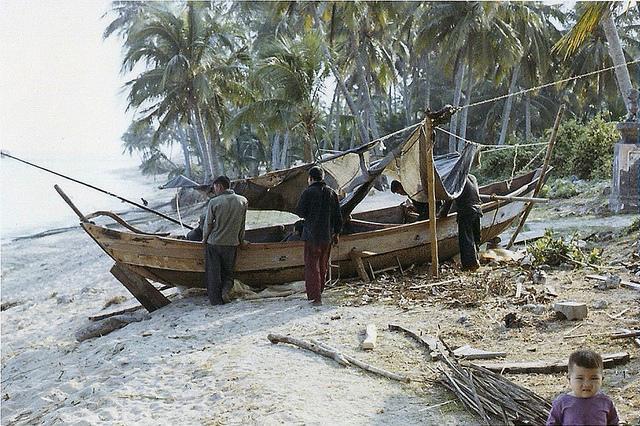Who is in the front right corner?
Choose the correct response, then elucidate: 'Answer: answer
Rationale: rationale.'
Options: Old woman, little child, old man, school teacher. Answer: little child.
Rationale: There is a small child in the right front corner of the photo. What would be the most useful material for adding to the boat in this image?
Select the correct answer and articulate reasoning with the following format: 'Answer: answer
Rationale: rationale.'
Options: Child, block, sticks, clothes. Answer: sticks.
Rationale: There is a pile of sticks as if they are being used to build the boat. 